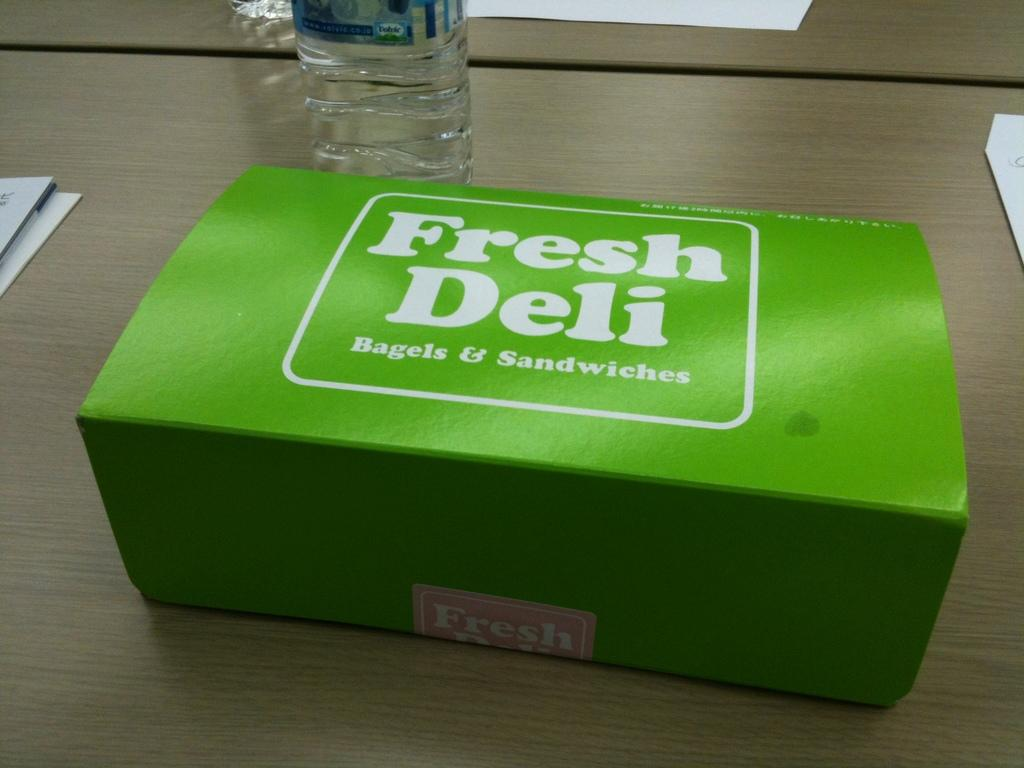<image>
Write a terse but informative summary of the picture. a green box on a table labeled 'fresh deli bagels & sandwiches' in white 